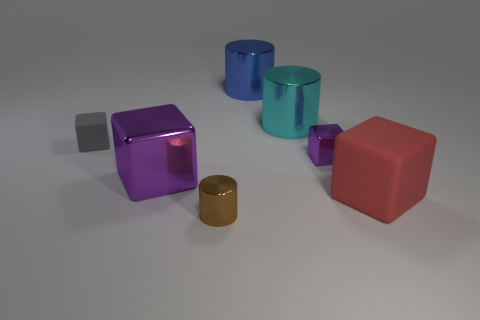There is another cube that is the same color as the big shiny block; what size is it?
Make the answer very short. Small. Is there a tiny object of the same color as the big metallic cube?
Provide a short and direct response. Yes. How many cyan metal objects are the same size as the red matte thing?
Your answer should be compact. 1. What is the shape of the metallic object that is the same color as the tiny metal cube?
Keep it short and to the point. Cube. What number of objects are metallic things on the right side of the big blue metal object or large purple metallic blocks?
Provide a short and direct response. 3. Are there fewer tiny metal cubes than tiny things?
Ensure brevity in your answer.  Yes. What is the shape of the large blue thing that is made of the same material as the tiny purple object?
Provide a succinct answer. Cylinder. Are there any matte things on the left side of the brown metal cylinder?
Give a very brief answer. Yes. Is the number of big shiny things behind the cyan cylinder less than the number of cyan things?
Provide a short and direct response. No. What is the material of the tiny gray block?
Offer a very short reply. Rubber. 